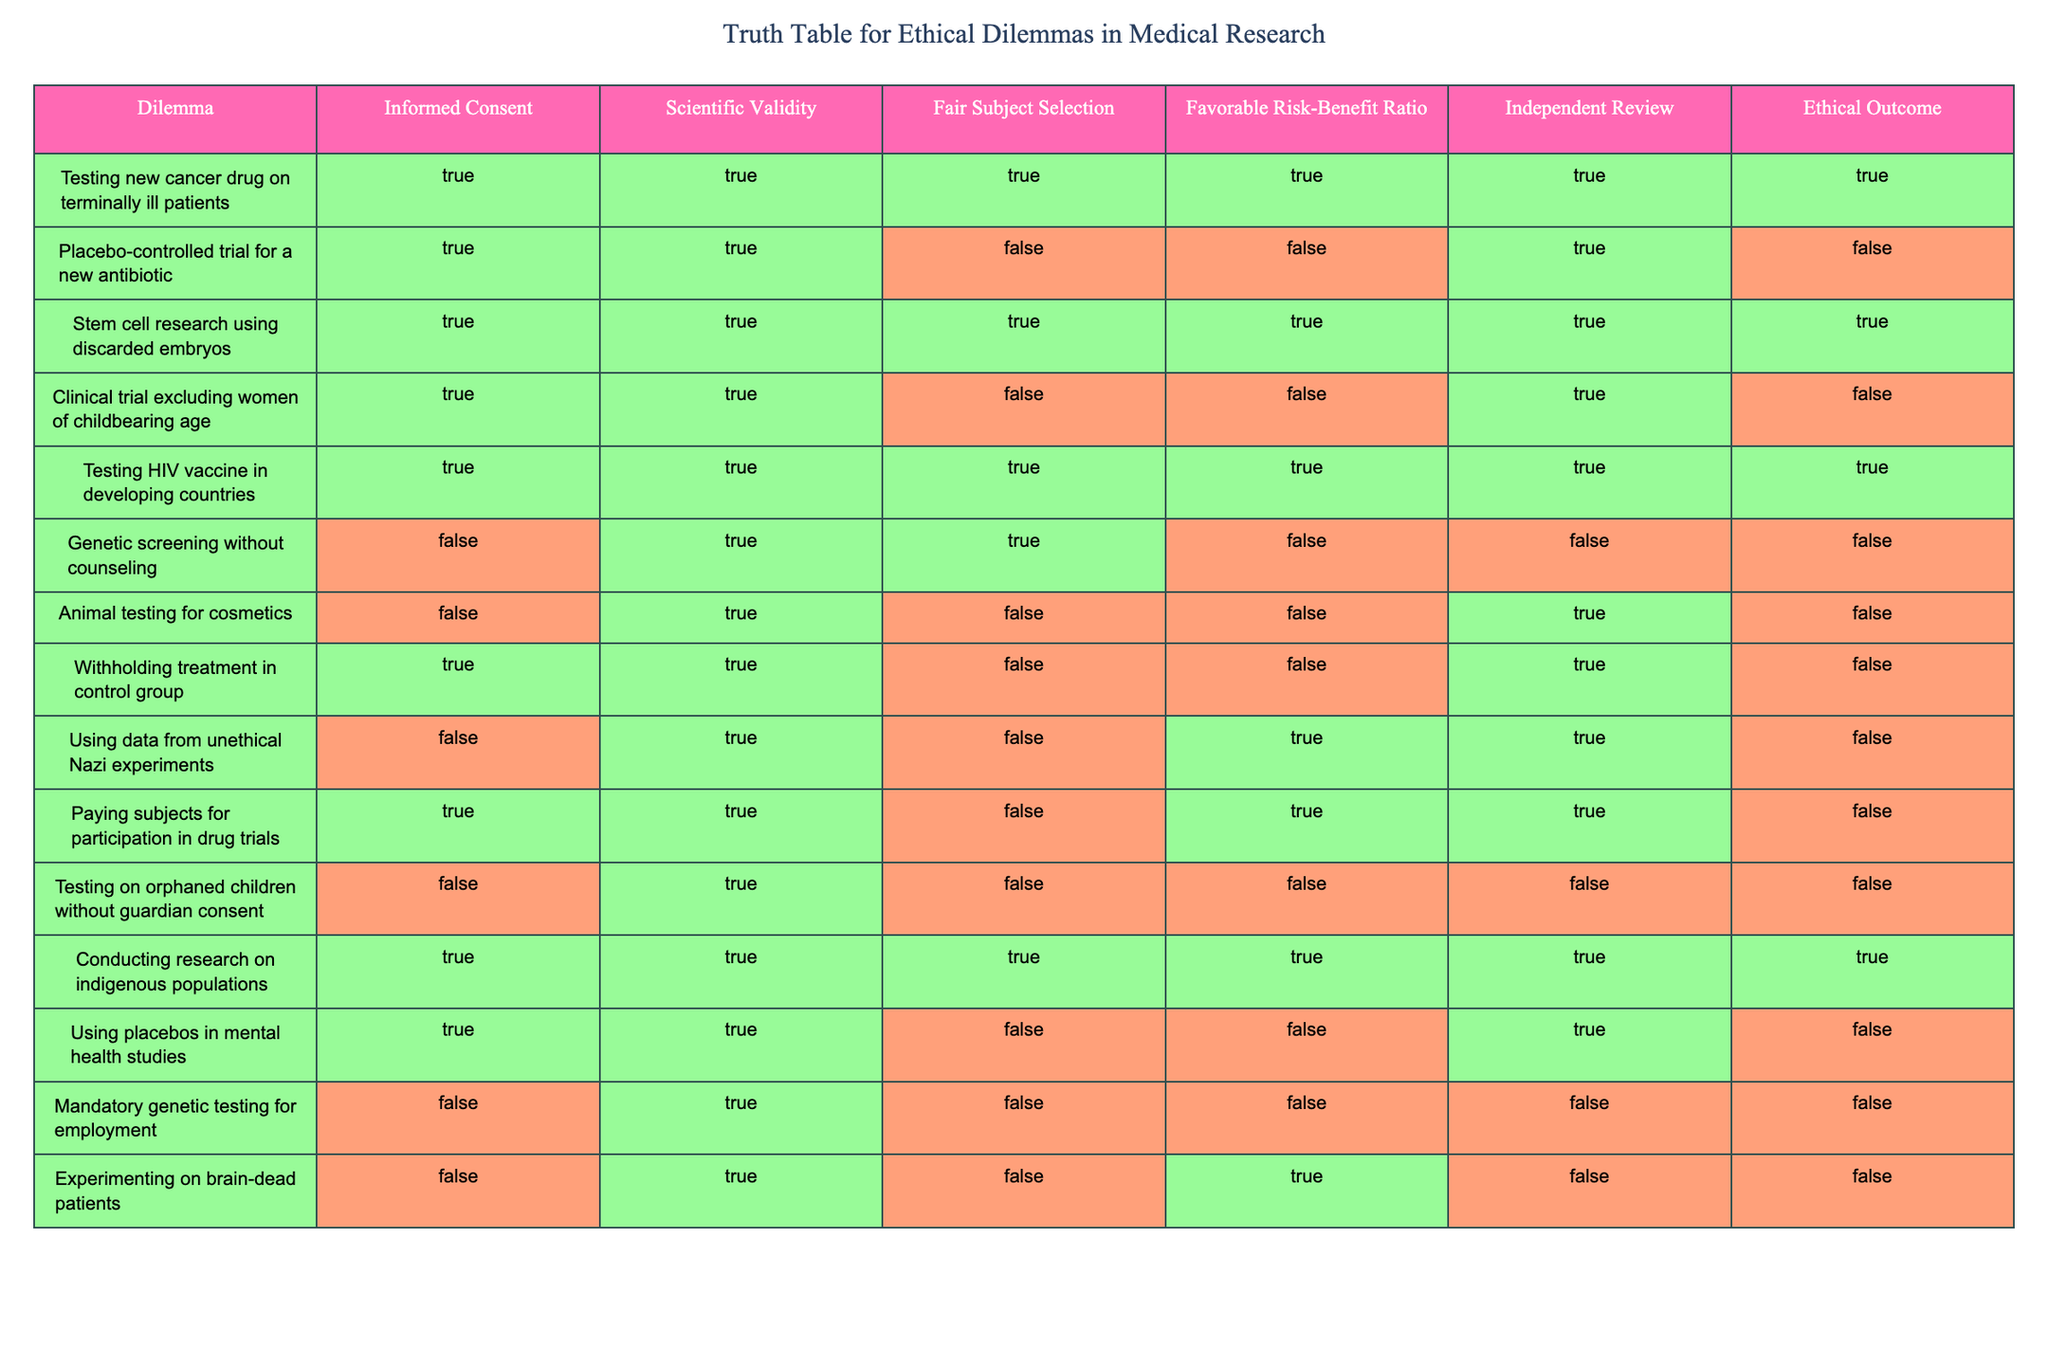What is the ethical outcome for testing a new cancer drug on terminally ill patients? The table indicates that the ethical outcome for this dilemma is marked as true (TRUE). By directly looking at the row corresponding to "Testing new cancer drug on terminally ill patients," we see that it satisfies all ethical criteria, hence it results in a favorable ethical outcome.
Answer: True Which dilemma has a favorable risk-benefit ratio but lacks scientific validity? By examining the table, the dilemma that has a favorable risk-benefit ratio (TRUE) but lacks scientific validity (FALSE) is the "Paying subjects for participation in drug trials." We find it in the row for that dilemma where the corresponding values indicate it meets the first criterion but not the second.
Answer: Paying subjects for participation in drug trials How many dilemmas exclude women of childbearing age in their ethical assessment? From the table, we observe two dilemmas that explicitly mention the exclusion of women of childbearing age, which are "Clinical trial excluding women of childbearing age" and "Testing on orphaned children without guardian consent." Only the first directly states it, but we can infer exclusion from the characteristics of the other. Therefore, a total of two instances can be counted.
Answer: 1 Is informed consent achieved in the genetic screening without counseling? The dilemma described in the table as "Genetic screening without counseling" indicates that informed consent has not been achieved (FALSE). By directly looking at that row, we can conclude that, despite other ethical factors being met, this particular aspect is marked false.
Answer: No What percentage of dilemmas conducted independent reviews? Counting the rows where "Independent Review" is marked TRUE, we find seven such dilemmas (Testing new cancer drug on terminally ill patients, Placebo-controlled trial for a new antibiotic, Stem cell research using discarded embryos, Testing HIV vaccine in developing countries, Conducting research on indigenous populations, Using placebos in mental health studies, and Paying subjects for participation in drug trials). Since there are a total of 15 dilemmas, the percentage can be calculated as (7/15)*100, which equals 46.67%.
Answer: 46.67% What is the dilemma with the most number of ethical violations according to the table? Analyzing the ethical dilemmas, the dilemma with the most ethical violations appears to be "Testing on orphaned children without guardian consent," which lacks informed consent, favorable risk-benefit ratio, and independent review (all marked FALSE). This has three ethical violations in total, which is higher compared to other dilemmas.
Answer: Testing on orphaned children without guardian consent Which dilemma meets all ethical criteria, including the favorable risk-benefit ratio? The dilemma that meets all five ethical criteria, including the favorable risk-benefit ratio (TRUE), is "Testing new cancer drug on terminally ill patients." A look at its associated values shows that it is fully compliant with all ethical standards outlined in the table.
Answer: Testing new cancer drug on terminally ill patients Is it ethical to use data from unethical Nazi experiments according to the table? The table categorically states that using data from unethical Nazi experiments is deemed unethical, as it lacks informed consent (FALSE) and has mixed results in ethical assessment. Thus, we conclude that it is not ethical.
Answer: No How many total dilemmas were marked with TRUE for all ethical outcomes? By observing the table, we find that there are four dilemmas marked as TRUE across all ethical categories: "Testing new cancer drug on terminally ill patients," "Stem cell research using discarded embryos," "Testing HIV vaccine in developing countries," and "Conducting research on indigenous populations." Totaling these, we find four that fit the criterion.
Answer: 4 